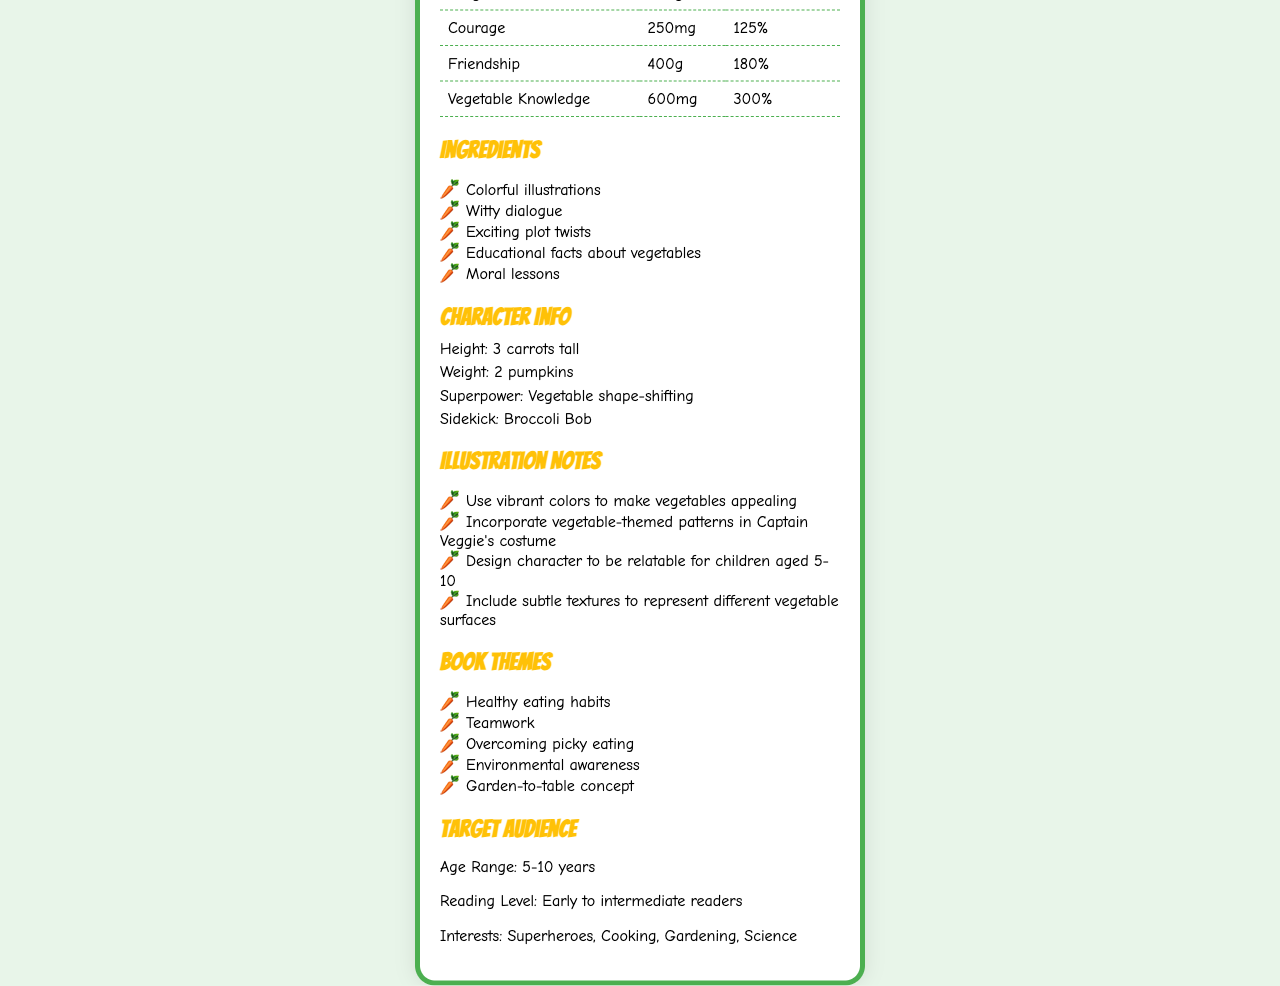who is the sidekick of Captain Veggie? The character info section clearly states that the sidekick of Captain Veggie is Broccoli Bob.
Answer: Broccoli Bob what is the serving size of the book? The serving info section mentions that the serving size of the book is 1 adventure (240 pages).
Answer: 1 adventure (240 pages) how much is the daily value of Vegetable Knowledge? In the nutrition facts table, the row for Vegetable Knowledge shows a daily value of 300%.
Answer: 300% list one ingredient mentioned in the ingredients section. The ingredients section includes Colorful illustrations, among others.
Answer: Colorful illustrations what is Captain Veggie's superpower? The character info section specifies that Captain Veggie's superpower is Vegetable shape-shifting.
Answer: Vegetable shape-shifting how many servings are in each book? The serving info section indicates that there is 1 serving per book.
Answer: 1 what is Captain Veggie's height described as? The character info section describes Captain Veggie's height as 3 carrots tall.
Answer: 3 carrots tall which nutrient has the highest daily value? A. Imagination B. Laughter C. Vegetable Knowledge D. Courage According to the nutrition facts table, Vegetable Knowledge has the highest daily value of 300%.
Answer: C what target age range is the book aimed at? A. 3-8 years B. 5-10 years C. 7-12 years D. 9-14 years The target audience section specifies that the book is aimed at children aged 5-10 years.
Answer: B is Captain Veggie's weight listed? The character info section lists Captain Veggie's weight as 2 pumpkins.
Answer: Yes what are the main themes of the book? The book themes section lists these five main themes.
Answer: Healthy eating habits, Teamwork, Overcoming picky eating, Environmental awareness, Garden-to-table concept does the book include any educational facts about vegetables? The ingredients section explicitly includes "Educational facts about vegetables" as one of the ingredients.
Answer: Yes describe the document. The document is essentially a playful and creative nutrition facts label tailored to reflect the content and characters of a children's book about Captain Veggie, a superhero promoting healthy eating.
Answer: The document is a colorful, character-shaped nutrition label for a children's book hero named Captain Veggie. It includes serving size, nutrition facts, ingredients, character info, illustration notes, book themes, and target audience. The label uses playful language and vibrant visuals to engage children. how many colors should be used for Captain Veggie's costume? Though the illustration notes mention using vibrant colors, it does not specify the number of colors to be used.
Answer: Not enough information what is one of the interests of the target audience? The target audience section lists several interests, including Superheroes.
Answer: Superheroes 